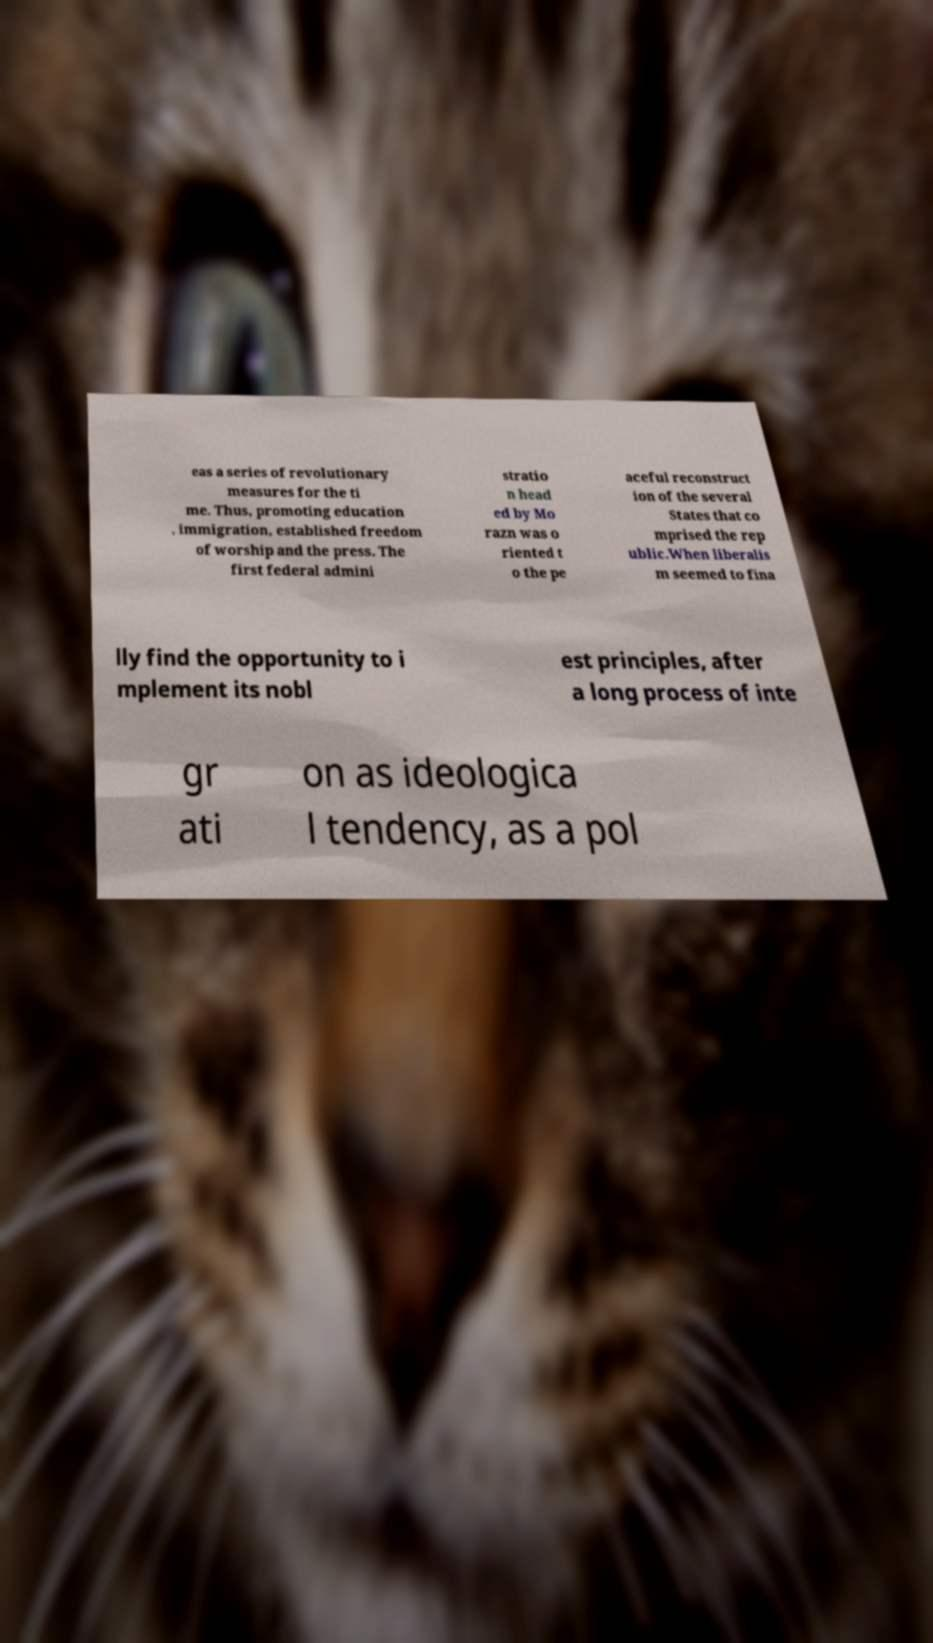I need the written content from this picture converted into text. Can you do that? eas a series of revolutionary measures for the ti me. Thus, promoting education , immigration, established freedom of worship and the press. The first federal admini stratio n head ed by Mo razn was o riented t o the pe aceful reconstruct ion of the several States that co mprised the rep ublic.When liberalis m seemed to fina lly find the opportunity to i mplement its nobl est principles, after a long process of inte gr ati on as ideologica l tendency, as a pol 